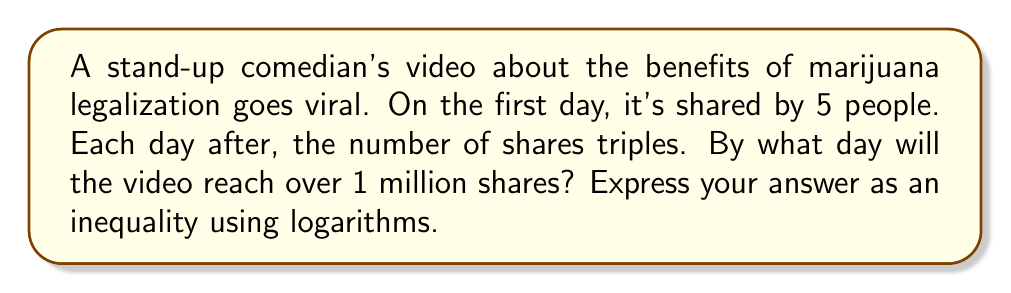Can you solve this math problem? Let's approach this step-by-step:

1) Let $n$ be the number of days after the first day.

2) The number of shares on day $n$ can be expressed as:
   $5 \cdot 3^n$

3) We want to find when this exceeds 1 million:
   $5 \cdot 3^n > 1,000,000$

4) Divide both sides by 5:
   $3^n > 200,000$

5) Take the logarithm (base 3) of both sides:
   $\log_3(3^n) > \log_3(200,000)$

6) Simplify the left side:
   $n > \log_3(200,000)$

7) We can change this to base 10 logarithm:
   $n > \frac{\log(200,000)}{\log(3)}$

8) Calculate this value:
   $n > \frac{5.30103}{0.47712} \approx 11.11$

9) Since $n$ must be a whole number of days, we need the smallest integer greater than 11.11.

Therefore, the video will reach over 1 million shares on day 12.
Answer: $n > \log_3(200,000)$ or $n \geq 12$ 